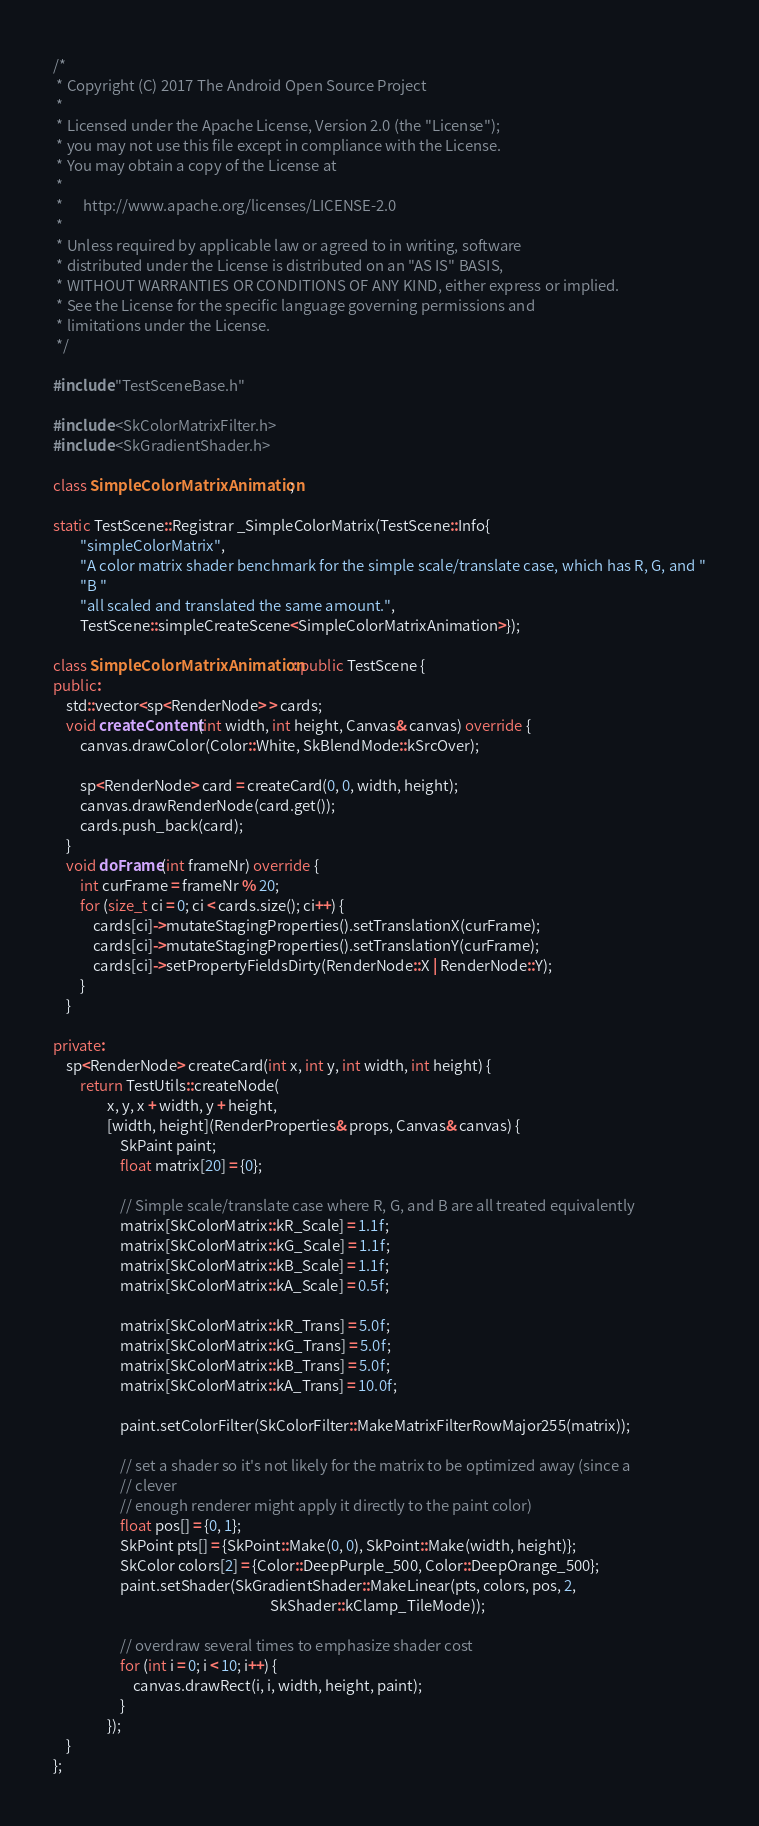Convert code to text. <code><loc_0><loc_0><loc_500><loc_500><_C++_>/*
 * Copyright (C) 2017 The Android Open Source Project
 *
 * Licensed under the Apache License, Version 2.0 (the "License");
 * you may not use this file except in compliance with the License.
 * You may obtain a copy of the License at
 *
 *      http://www.apache.org/licenses/LICENSE-2.0
 *
 * Unless required by applicable law or agreed to in writing, software
 * distributed under the License is distributed on an "AS IS" BASIS,
 * WITHOUT WARRANTIES OR CONDITIONS OF ANY KIND, either express or implied.
 * See the License for the specific language governing permissions and
 * limitations under the License.
 */

#include "TestSceneBase.h"

#include <SkColorMatrixFilter.h>
#include <SkGradientShader.h>

class SimpleColorMatrixAnimation;

static TestScene::Registrar _SimpleColorMatrix(TestScene::Info{
        "simpleColorMatrix",
        "A color matrix shader benchmark for the simple scale/translate case, which has R, G, and "
        "B "
        "all scaled and translated the same amount.",
        TestScene::simpleCreateScene<SimpleColorMatrixAnimation>});

class SimpleColorMatrixAnimation : public TestScene {
public:
    std::vector<sp<RenderNode> > cards;
    void createContent(int width, int height, Canvas& canvas) override {
        canvas.drawColor(Color::White, SkBlendMode::kSrcOver);

        sp<RenderNode> card = createCard(0, 0, width, height);
        canvas.drawRenderNode(card.get());
        cards.push_back(card);
    }
    void doFrame(int frameNr) override {
        int curFrame = frameNr % 20;
        for (size_t ci = 0; ci < cards.size(); ci++) {
            cards[ci]->mutateStagingProperties().setTranslationX(curFrame);
            cards[ci]->mutateStagingProperties().setTranslationY(curFrame);
            cards[ci]->setPropertyFieldsDirty(RenderNode::X | RenderNode::Y);
        }
    }

private:
    sp<RenderNode> createCard(int x, int y, int width, int height) {
        return TestUtils::createNode(
                x, y, x + width, y + height,
                [width, height](RenderProperties& props, Canvas& canvas) {
                    SkPaint paint;
                    float matrix[20] = {0};

                    // Simple scale/translate case where R, G, and B are all treated equivalently
                    matrix[SkColorMatrix::kR_Scale] = 1.1f;
                    matrix[SkColorMatrix::kG_Scale] = 1.1f;
                    matrix[SkColorMatrix::kB_Scale] = 1.1f;
                    matrix[SkColorMatrix::kA_Scale] = 0.5f;

                    matrix[SkColorMatrix::kR_Trans] = 5.0f;
                    matrix[SkColorMatrix::kG_Trans] = 5.0f;
                    matrix[SkColorMatrix::kB_Trans] = 5.0f;
                    matrix[SkColorMatrix::kA_Trans] = 10.0f;

                    paint.setColorFilter(SkColorFilter::MakeMatrixFilterRowMajor255(matrix));

                    // set a shader so it's not likely for the matrix to be optimized away (since a
                    // clever
                    // enough renderer might apply it directly to the paint color)
                    float pos[] = {0, 1};
                    SkPoint pts[] = {SkPoint::Make(0, 0), SkPoint::Make(width, height)};
                    SkColor colors[2] = {Color::DeepPurple_500, Color::DeepOrange_500};
                    paint.setShader(SkGradientShader::MakeLinear(pts, colors, pos, 2,
                                                                 SkShader::kClamp_TileMode));

                    // overdraw several times to emphasize shader cost
                    for (int i = 0; i < 10; i++) {
                        canvas.drawRect(i, i, width, height, paint);
                    }
                });
    }
};
</code> 